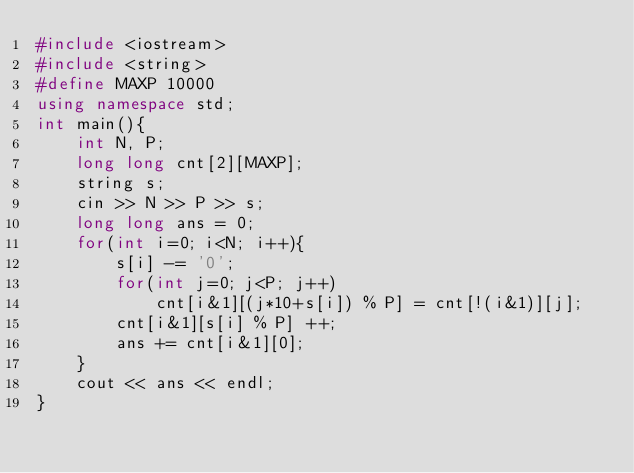Convert code to text. <code><loc_0><loc_0><loc_500><loc_500><_C++_>#include <iostream>
#include <string>
#define MAXP 10000
using namespace std;
int main(){
	int N, P;
	long long cnt[2][MAXP];
	string s;
	cin >> N >> P >> s;
	long long ans = 0;
	for(int i=0; i<N; i++){
		s[i] -= '0';
		for(int j=0; j<P; j++)
			cnt[i&1][(j*10+s[i]) % P] = cnt[!(i&1)][j];
		cnt[i&1][s[i] % P] ++;
		ans += cnt[i&1][0];
	}
	cout << ans << endl;
}
	

</code> 